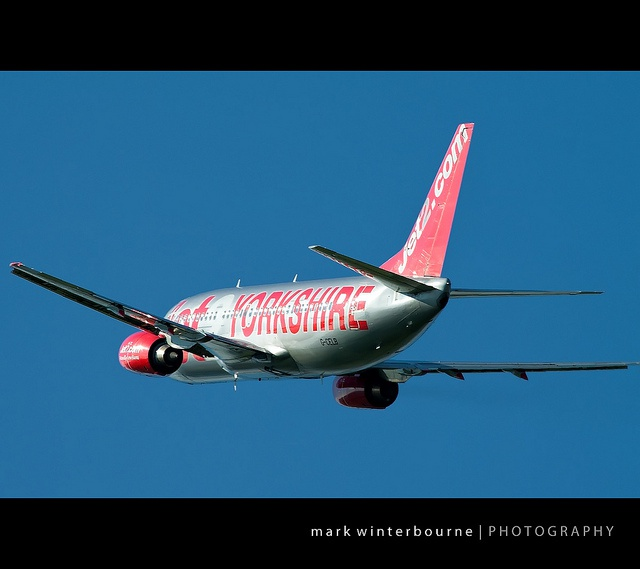Describe the objects in this image and their specific colors. I can see a airplane in black, white, blue, and gray tones in this image. 